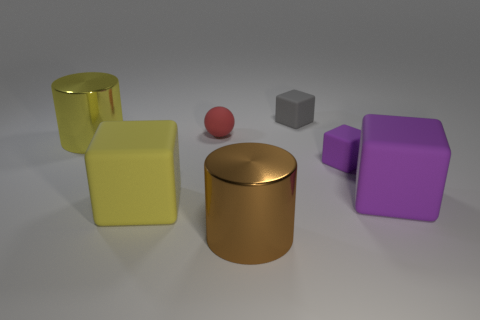Subtract all purple cubes. How many were subtracted if there are1purple cubes left? 1 Subtract all small gray blocks. How many blocks are left? 3 Subtract all gray cubes. How many cubes are left? 3 Add 2 brown matte objects. How many objects exist? 9 Subtract all blue cubes. Subtract all blue cylinders. How many cubes are left? 4 Subtract all cylinders. How many objects are left? 5 Add 7 large cylinders. How many large cylinders exist? 9 Subtract 0 gray cylinders. How many objects are left? 7 Subtract all tiny yellow balls. Subtract all small matte spheres. How many objects are left? 6 Add 3 brown metal things. How many brown metal things are left? 4 